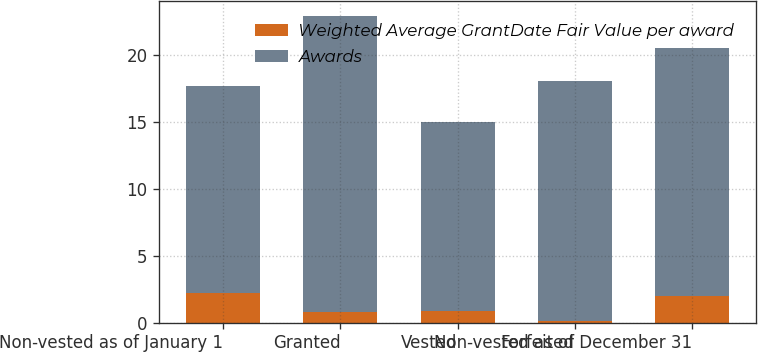Convert chart. <chart><loc_0><loc_0><loc_500><loc_500><stacked_bar_chart><ecel><fcel>Non-vested as of January 1<fcel>Granted<fcel>Vested<fcel>Forfeited<fcel>Non-vested as of December 31<nl><fcel>Weighted Average GrantDate Fair Value per award<fcel>2.2<fcel>0.8<fcel>0.9<fcel>0.1<fcel>2<nl><fcel>Awards<fcel>15.47<fcel>22.07<fcel>14.1<fcel>17.92<fcel>18.53<nl></chart> 